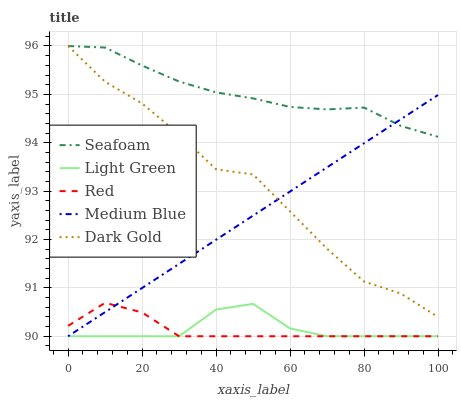Does Red have the minimum area under the curve?
Answer yes or no. Yes. Does Medium Blue have the minimum area under the curve?
Answer yes or no. No. Does Medium Blue have the maximum area under the curve?
Answer yes or no. No. Is Seafoam the smoothest?
Answer yes or no. No. Is Seafoam the roughest?
Answer yes or no. No. Does Seafoam have the lowest value?
Answer yes or no. No. Does Medium Blue have the highest value?
Answer yes or no. No. Is Light Green less than Seafoam?
Answer yes or no. Yes. Is Seafoam greater than Red?
Answer yes or no. Yes. Does Light Green intersect Seafoam?
Answer yes or no. No. 